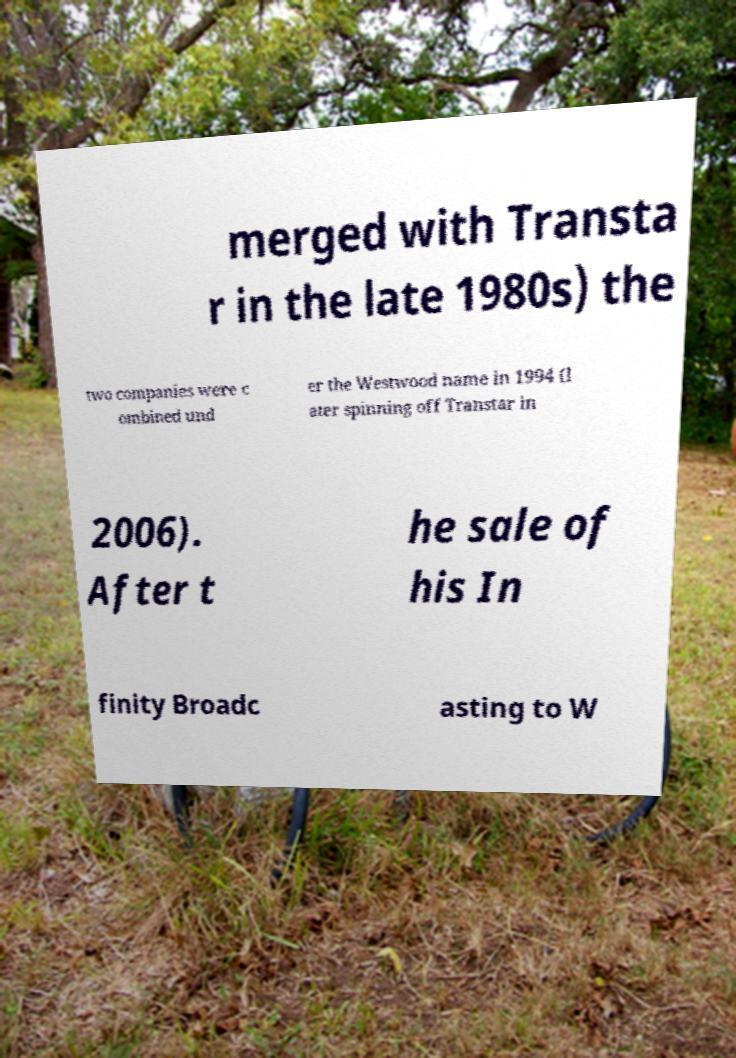Could you assist in decoding the text presented in this image and type it out clearly? merged with Transta r in the late 1980s) the two companies were c ombined und er the Westwood name in 1994 (l ater spinning off Transtar in 2006). After t he sale of his In finity Broadc asting to W 